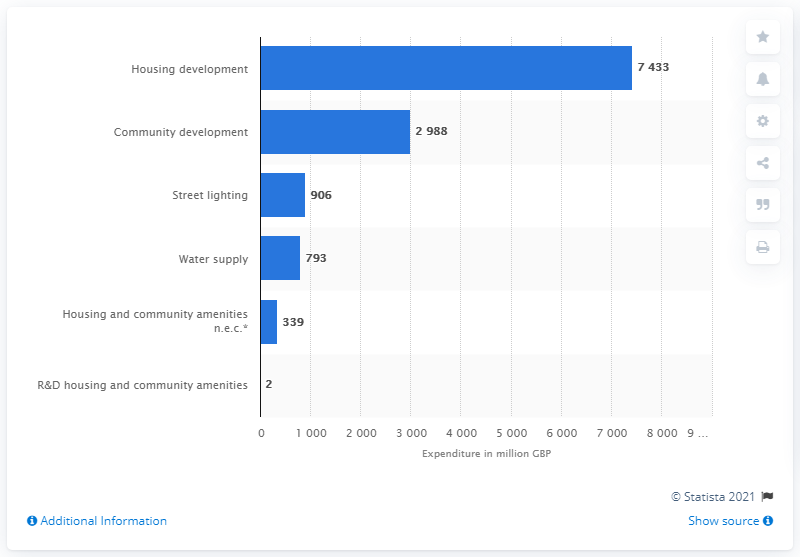Mention a couple of crucial points in this snapshot. In the 2018/19 fiscal year, a total of 7,433 British pounds were spent on housing development. 